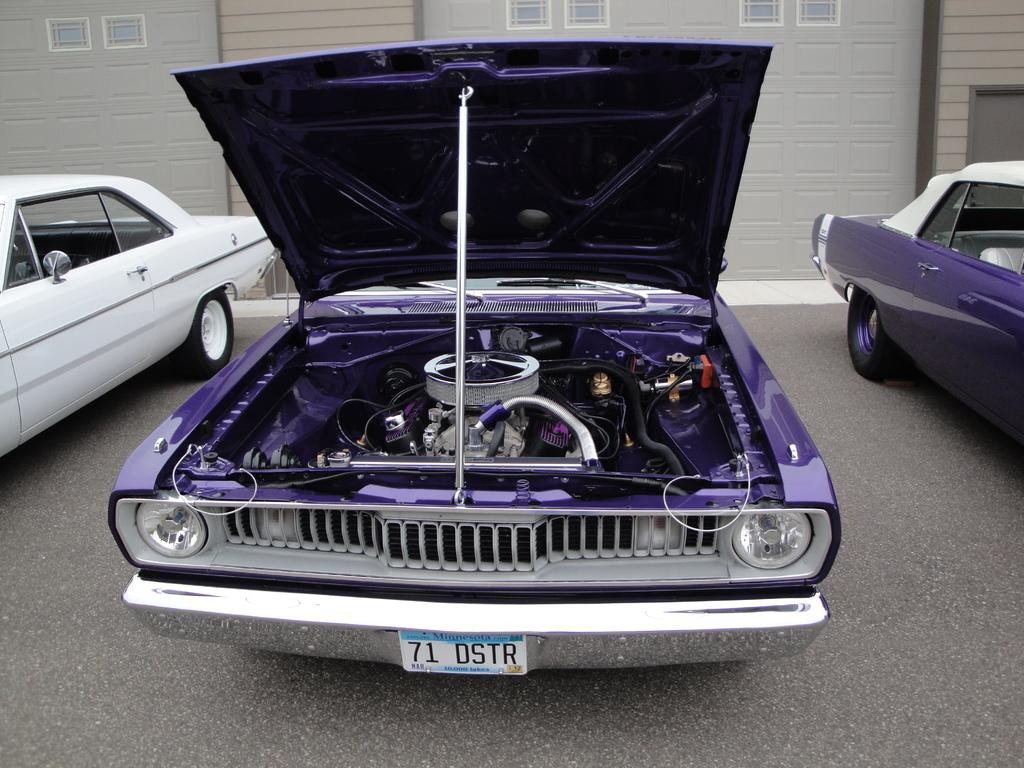How many vehicles can be seen on the road in the image? There are three vehicles on the road in the image. What is visible in the background of the image? There is a building with windows in the background of the image. What type of copper material is used to construct the vehicles in the image? There is no mention of copper or any specific materials used to construct the vehicles in the image. The vehicles are simply described as being present on the road. 